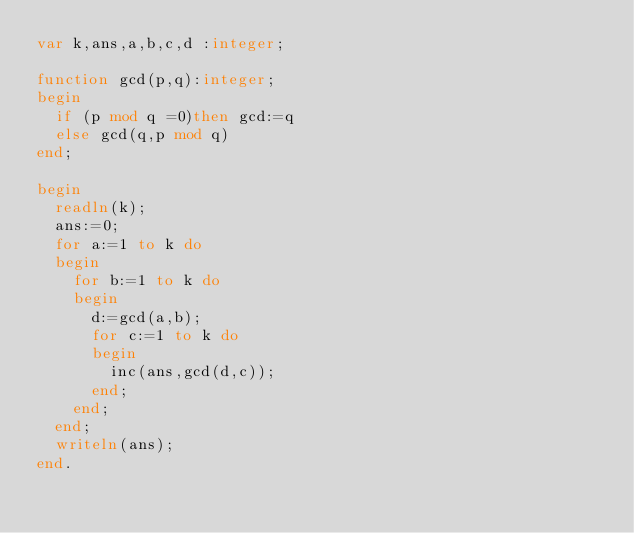Convert code to text. <code><loc_0><loc_0><loc_500><loc_500><_Pascal_>var k,ans,a,b,c,d :integer;

function gcd(p,q):integer;
begin
  if (p mod q =0)then gcd:=q
  else gcd(q,p mod q)
end;

begin
  readln(k);
  ans:=0;
  for a:=1 to k do
  begin
    for b:=1 to k do
    begin
      d:=gcd(a,b);
      for c:=1 to k do
      begin
        inc(ans,gcd(d,c));
      end;
    end;
  end;
  writeln(ans);
end.
</code> 